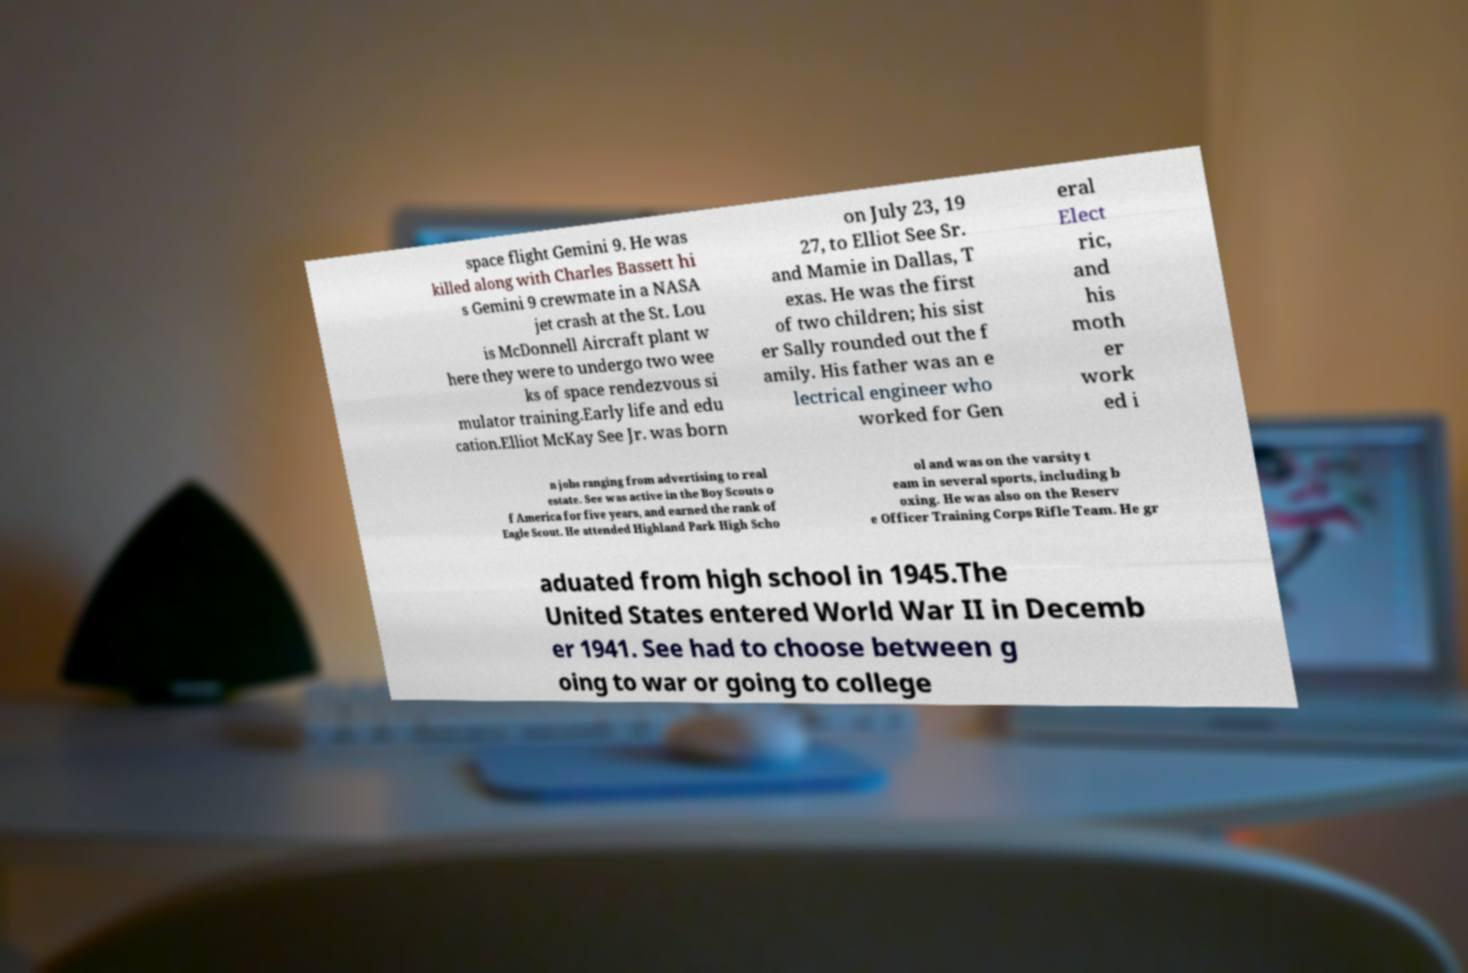Can you accurately transcribe the text from the provided image for me? space flight Gemini 9. He was killed along with Charles Bassett hi s Gemini 9 crewmate in a NASA jet crash at the St. Lou is McDonnell Aircraft plant w here they were to undergo two wee ks of space rendezvous si mulator training.Early life and edu cation.Elliot McKay See Jr. was born on July 23, 19 27, to Elliot See Sr. and Mamie in Dallas, T exas. He was the first of two children; his sist er Sally rounded out the f amily. His father was an e lectrical engineer who worked for Gen eral Elect ric, and his moth er work ed i n jobs ranging from advertising to real estate. See was active in the Boy Scouts o f America for five years, and earned the rank of Eagle Scout. He attended Highland Park High Scho ol and was on the varsity t eam in several sports, including b oxing. He was also on the Reserv e Officer Training Corps Rifle Team. He gr aduated from high school in 1945.The United States entered World War II in Decemb er 1941. See had to choose between g oing to war or going to college 